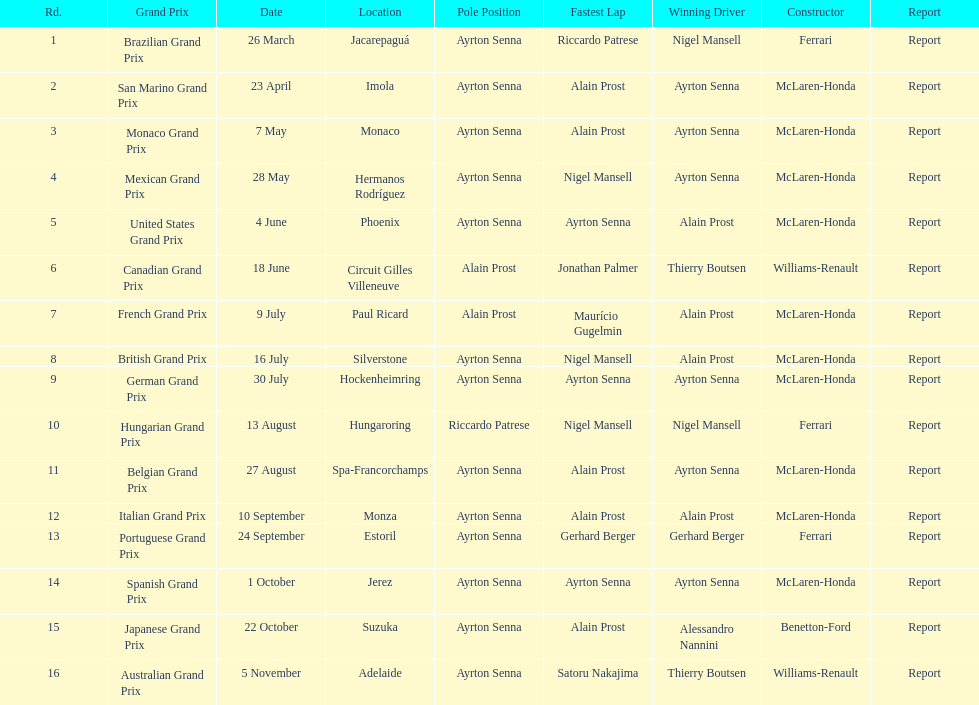Who was the victor of the spanish grand prix? McLaren-Honda. Parse the full table in json format. {'header': ['Rd.', 'Grand Prix', 'Date', 'Location', 'Pole Position', 'Fastest Lap', 'Winning Driver', 'Constructor', 'Report'], 'rows': [['1', 'Brazilian Grand Prix', '26 March', 'Jacarepaguá', 'Ayrton Senna', 'Riccardo Patrese', 'Nigel Mansell', 'Ferrari', 'Report'], ['2', 'San Marino Grand Prix', '23 April', 'Imola', 'Ayrton Senna', 'Alain Prost', 'Ayrton Senna', 'McLaren-Honda', 'Report'], ['3', 'Monaco Grand Prix', '7 May', 'Monaco', 'Ayrton Senna', 'Alain Prost', 'Ayrton Senna', 'McLaren-Honda', 'Report'], ['4', 'Mexican Grand Prix', '28 May', 'Hermanos Rodríguez', 'Ayrton Senna', 'Nigel Mansell', 'Ayrton Senna', 'McLaren-Honda', 'Report'], ['5', 'United States Grand Prix', '4 June', 'Phoenix', 'Ayrton Senna', 'Ayrton Senna', 'Alain Prost', 'McLaren-Honda', 'Report'], ['6', 'Canadian Grand Prix', '18 June', 'Circuit Gilles Villeneuve', 'Alain Prost', 'Jonathan Palmer', 'Thierry Boutsen', 'Williams-Renault', 'Report'], ['7', 'French Grand Prix', '9 July', 'Paul Ricard', 'Alain Prost', 'Maurício Gugelmin', 'Alain Prost', 'McLaren-Honda', 'Report'], ['8', 'British Grand Prix', '16 July', 'Silverstone', 'Ayrton Senna', 'Nigel Mansell', 'Alain Prost', 'McLaren-Honda', 'Report'], ['9', 'German Grand Prix', '30 July', 'Hockenheimring', 'Ayrton Senna', 'Ayrton Senna', 'Ayrton Senna', 'McLaren-Honda', 'Report'], ['10', 'Hungarian Grand Prix', '13 August', 'Hungaroring', 'Riccardo Patrese', 'Nigel Mansell', 'Nigel Mansell', 'Ferrari', 'Report'], ['11', 'Belgian Grand Prix', '27 August', 'Spa-Francorchamps', 'Ayrton Senna', 'Alain Prost', 'Ayrton Senna', 'McLaren-Honda', 'Report'], ['12', 'Italian Grand Prix', '10 September', 'Monza', 'Ayrton Senna', 'Alain Prost', 'Alain Prost', 'McLaren-Honda', 'Report'], ['13', 'Portuguese Grand Prix', '24 September', 'Estoril', 'Ayrton Senna', 'Gerhard Berger', 'Gerhard Berger', 'Ferrari', 'Report'], ['14', 'Spanish Grand Prix', '1 October', 'Jerez', 'Ayrton Senna', 'Ayrton Senna', 'Ayrton Senna', 'McLaren-Honda', 'Report'], ['15', 'Japanese Grand Prix', '22 October', 'Suzuka', 'Ayrton Senna', 'Alain Prost', 'Alessandro Nannini', 'Benetton-Ford', 'Report'], ['16', 'Australian Grand Prix', '5 November', 'Adelaide', 'Ayrton Senna', 'Satoru Nakajima', 'Thierry Boutsen', 'Williams-Renault', 'Report']]} Who triumphed in the italian grand prix? McLaren-Honda. Which grand prix was won by benneton-ford? Japanese Grand Prix. 